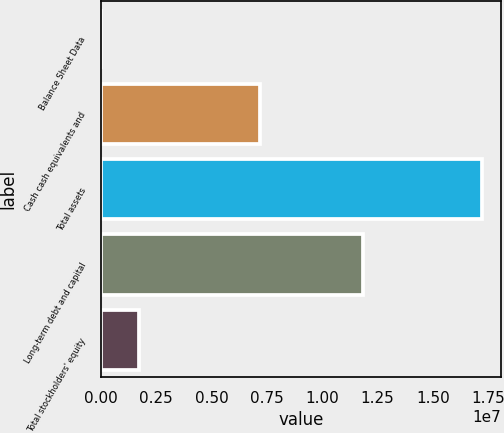<chart> <loc_0><loc_0><loc_500><loc_500><bar_chart><fcel>Balance Sheet Data<fcel>Cash cash equivalents and<fcel>Total assets<fcel>Long-term debt and capital<fcel>Total stockholders' equity<nl><fcel>2012<fcel>7.20538e+06<fcel>1.72299e+07<fcel>1.18317e+07<fcel>1.7248e+06<nl></chart> 